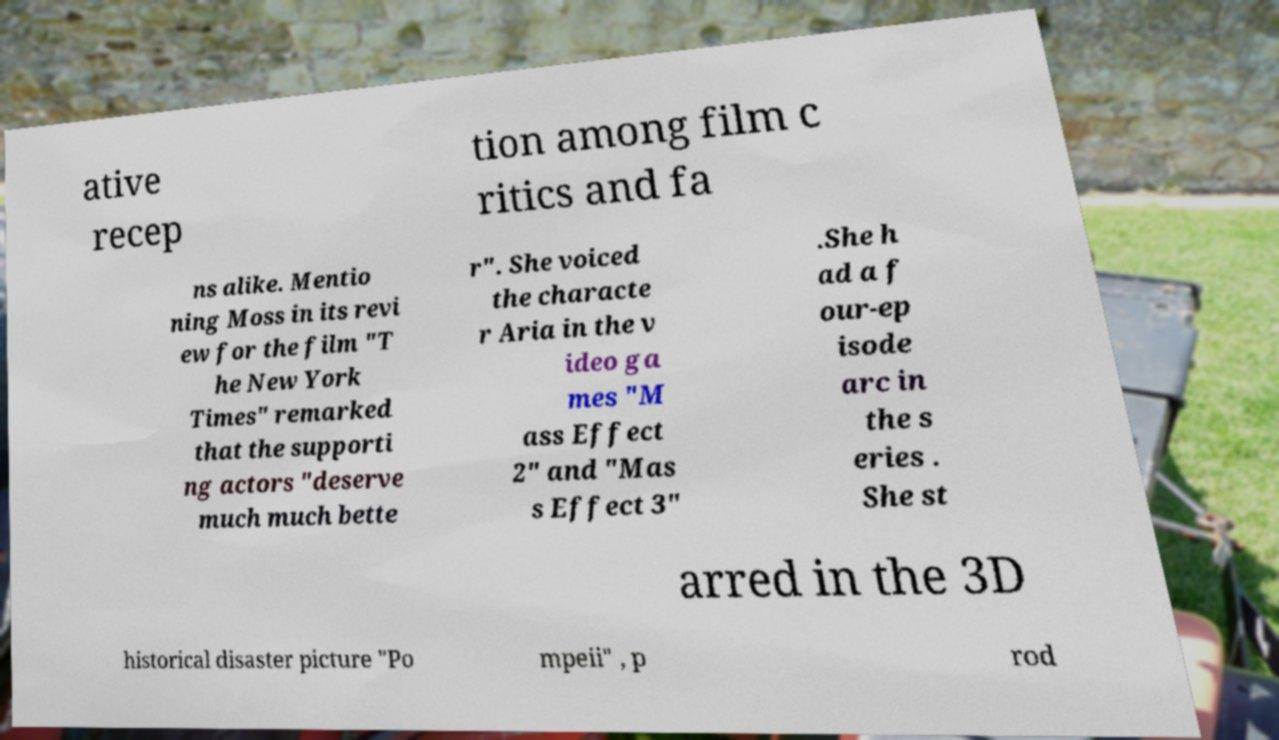Can you read and provide the text displayed in the image?This photo seems to have some interesting text. Can you extract and type it out for me? ative recep tion among film c ritics and fa ns alike. Mentio ning Moss in its revi ew for the film "T he New York Times" remarked that the supporti ng actors "deserve much much bette r". She voiced the characte r Aria in the v ideo ga mes "M ass Effect 2" and "Mas s Effect 3" .She h ad a f our-ep isode arc in the s eries . She st arred in the 3D historical disaster picture "Po mpeii" , p rod 